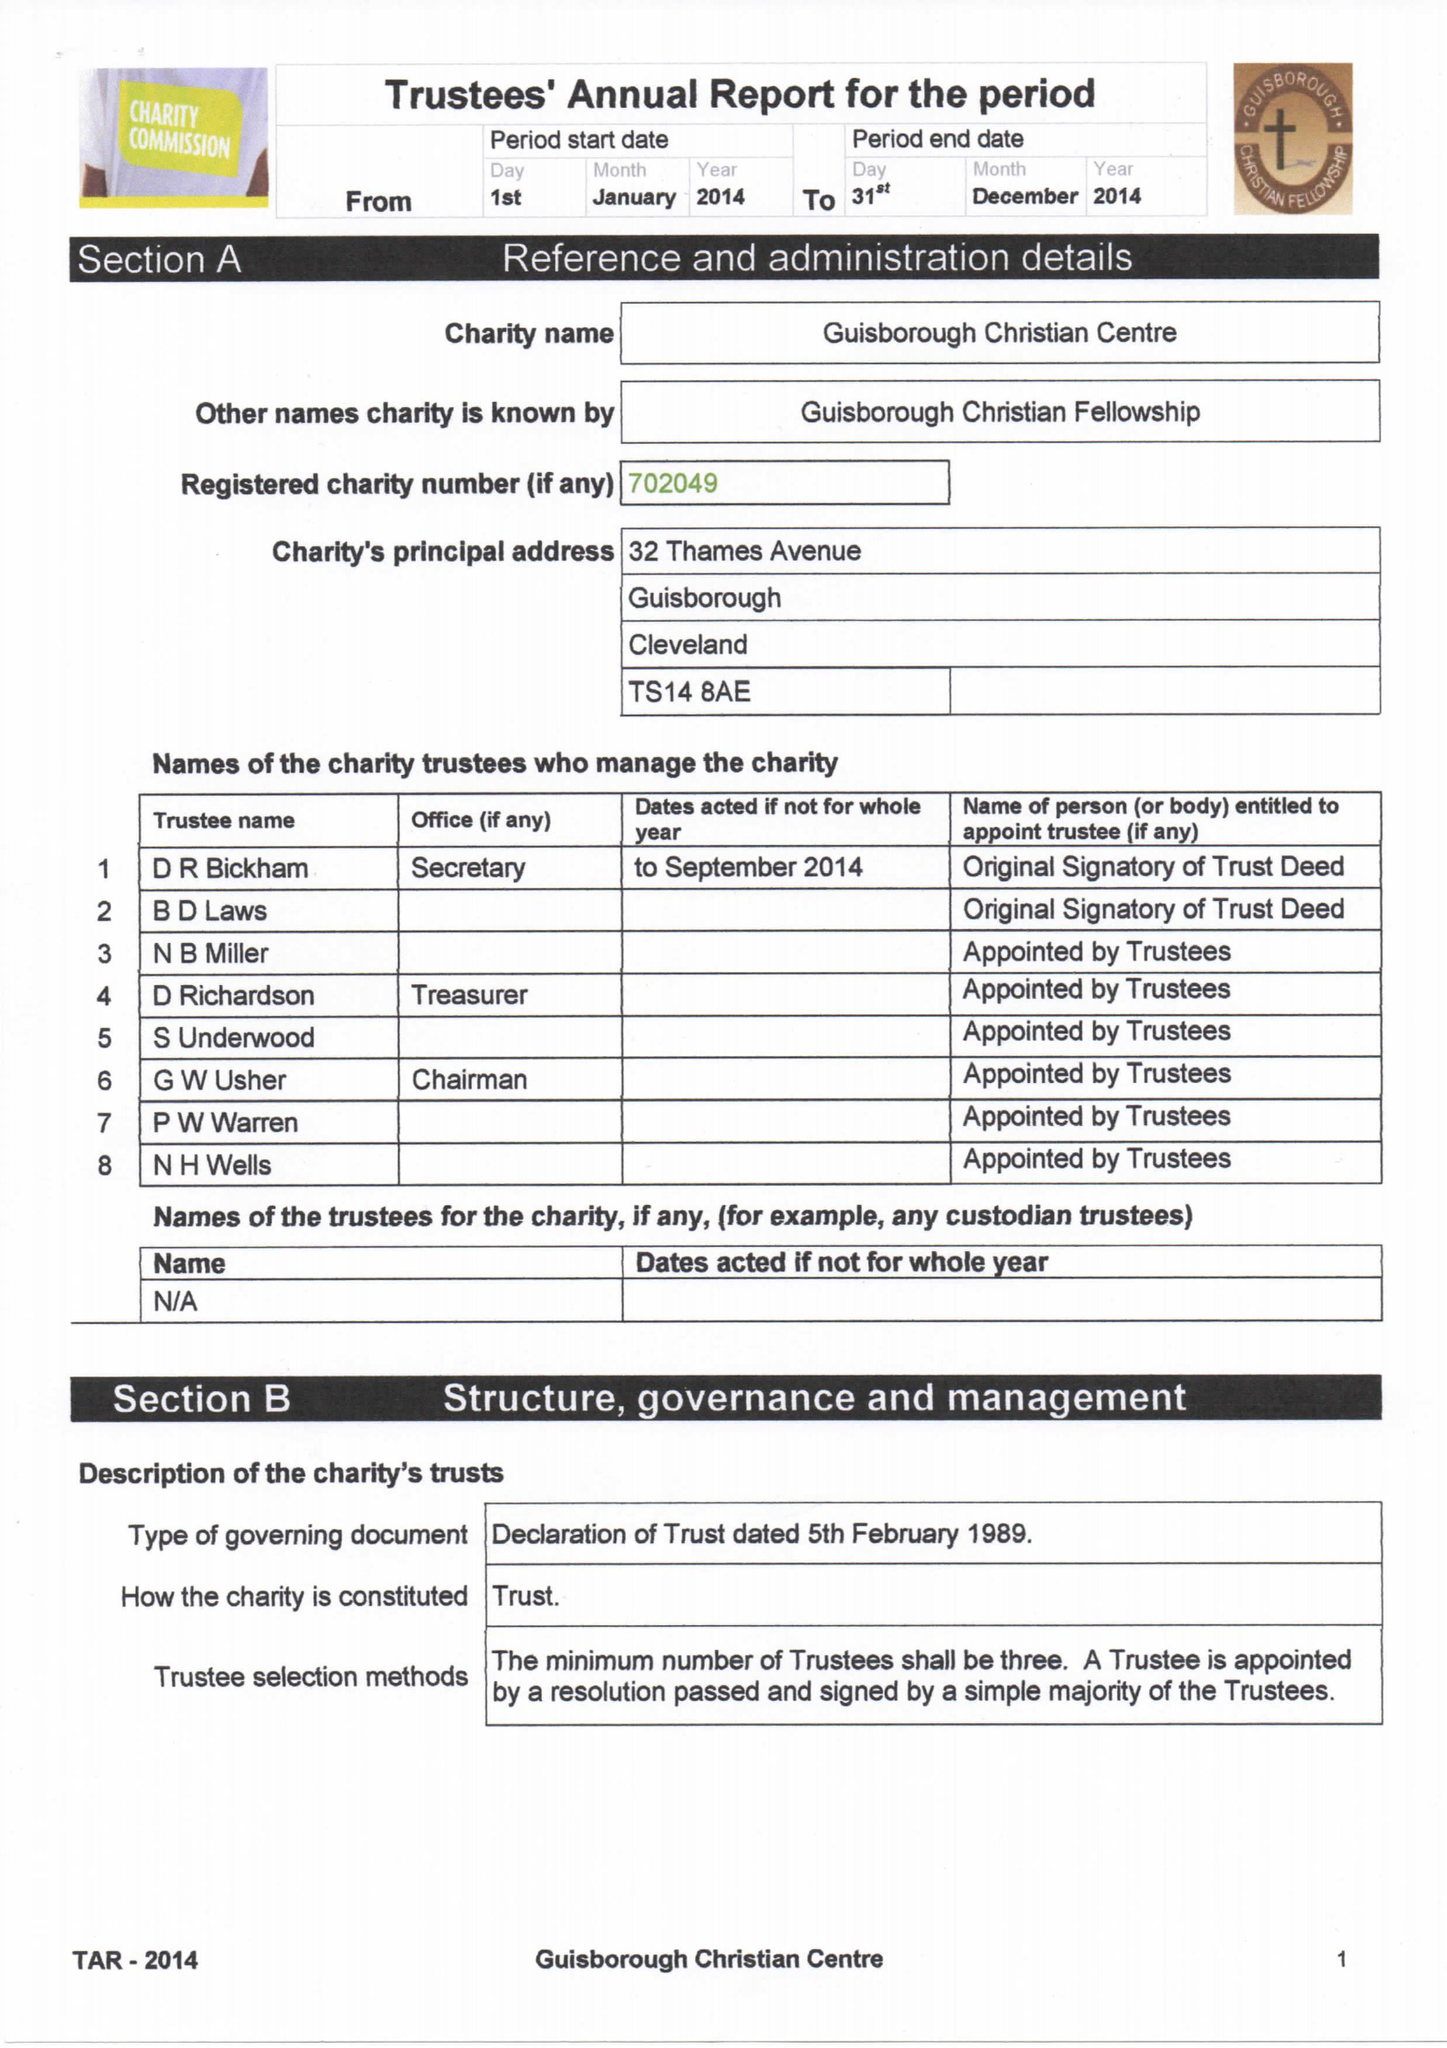What is the value for the address__street_line?
Answer the question using a single word or phrase. None 